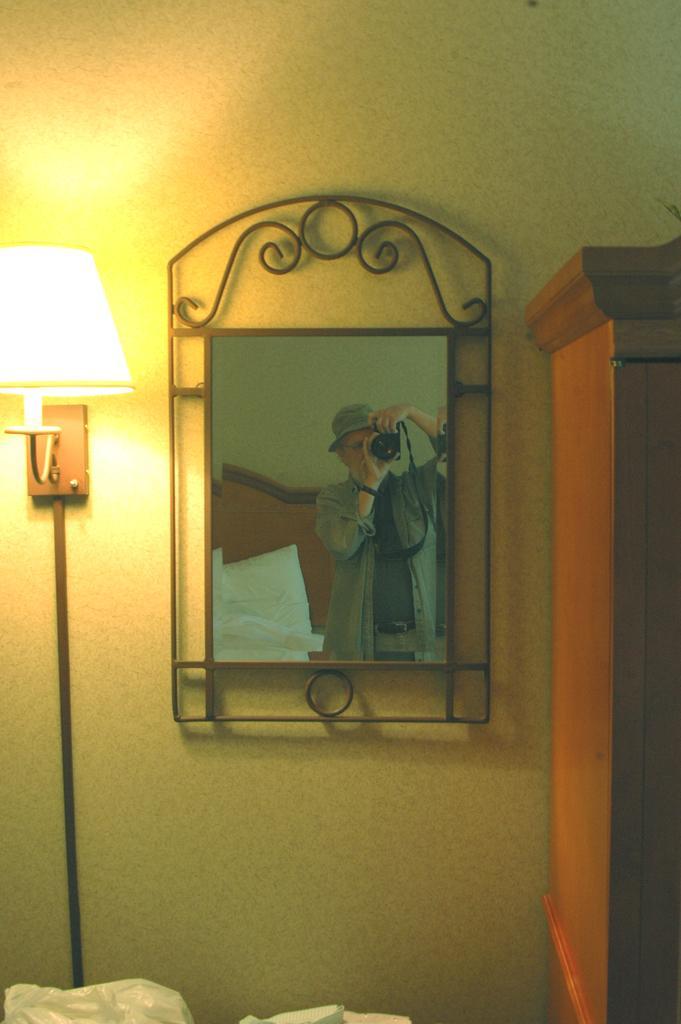Can you describe this image briefly? In this image I can see a photo frame in the center, there is a cabinet on the right and there is a lamp on the left. 